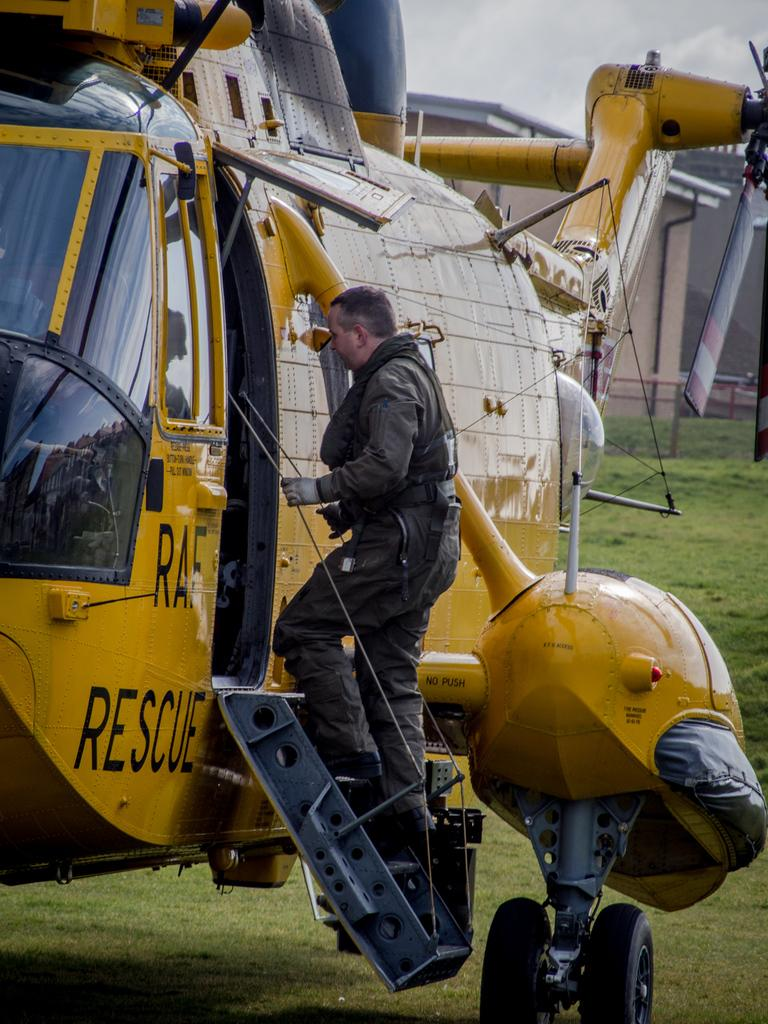<image>
Provide a brief description of the given image. Man getting on a rescue helicopter about to fly 